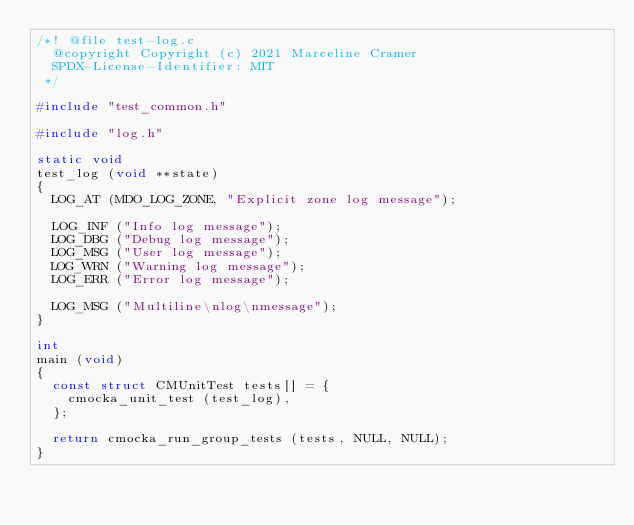<code> <loc_0><loc_0><loc_500><loc_500><_C_>/*! @file test-log.c
  @copyright Copyright (c) 2021 Marceline Cramer
  SPDX-License-Identifier: MIT
 */

#include "test_common.h"

#include "log.h"

static void
test_log (void **state)
{
  LOG_AT (MDO_LOG_ZONE, "Explicit zone log message");

  LOG_INF ("Info log message");
  LOG_DBG ("Debug log message");
  LOG_MSG ("User log message");
  LOG_WRN ("Warning log message");
  LOG_ERR ("Error log message");

  LOG_MSG ("Multiline\nlog\nmessage");
}

int
main (void)
{
  const struct CMUnitTest tests[] = {
    cmocka_unit_test (test_log),
  };

  return cmocka_run_group_tests (tests, NULL, NULL);
}
</code> 